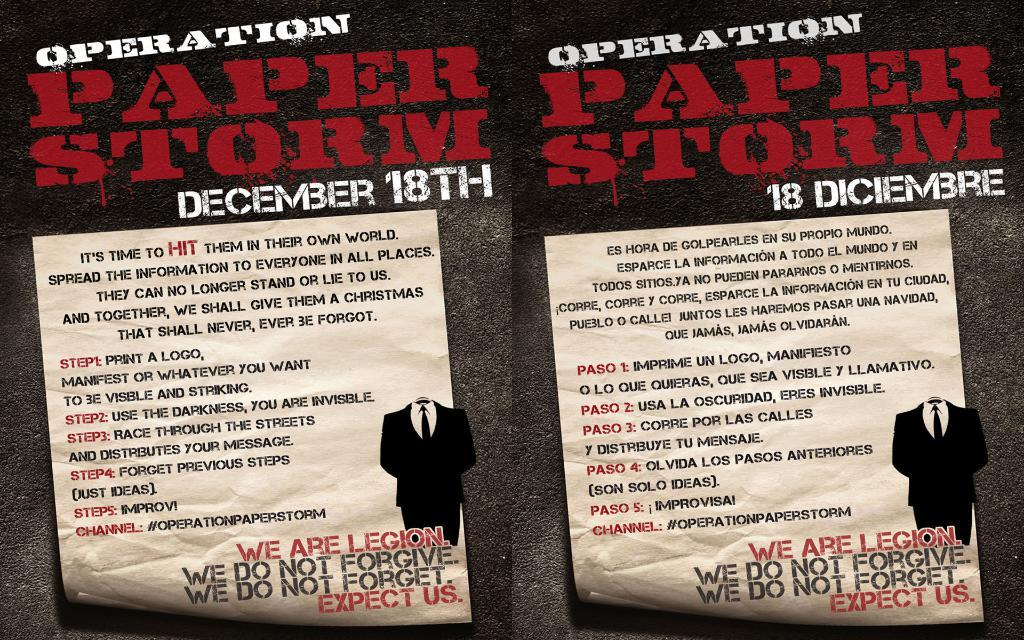What is depicted in the collage of two images? The collage consists of two images of the same scene. How do the images differ from each other? The images are in different languages. What objects can be seen in the images? Papers are visible in the images. What is a common feature in both images? There is text present in both images. What type of sofa is shown in the images? There is no sofa present in the images; they depict a scene with papers and text. 